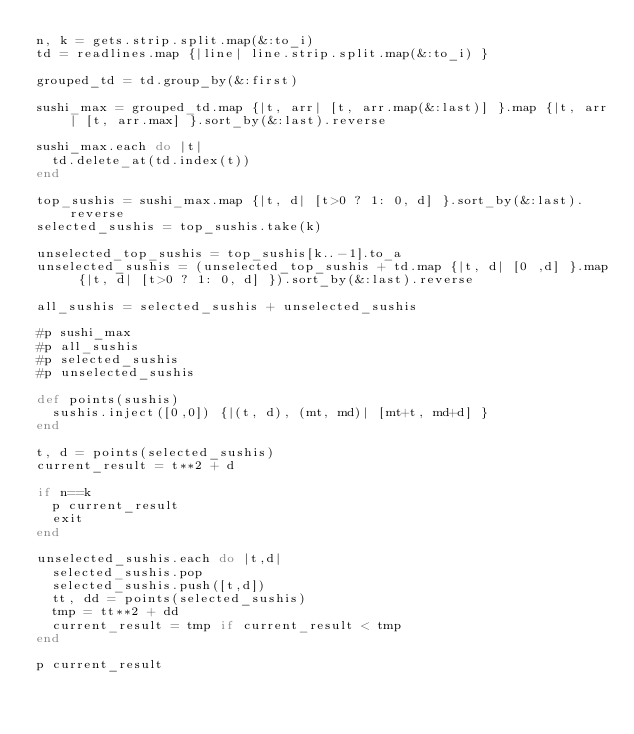Convert code to text. <code><loc_0><loc_0><loc_500><loc_500><_Ruby_>n, k = gets.strip.split.map(&:to_i)
td = readlines.map {|line| line.strip.split.map(&:to_i) }

grouped_td = td.group_by(&:first)

sushi_max = grouped_td.map {|t, arr| [t, arr.map(&:last)] }.map {|t, arr| [t, arr.max] }.sort_by(&:last).reverse

sushi_max.each do |t|
  td.delete_at(td.index(t))
end

top_sushis = sushi_max.map {|t, d| [t>0 ? 1: 0, d] }.sort_by(&:last).reverse
selected_sushis = top_sushis.take(k)

unselected_top_sushis = top_sushis[k..-1].to_a
unselected_sushis = (unselected_top_sushis + td.map {|t, d| [0 ,d] }.map {|t, d| [t>0 ? 1: 0, d] }).sort_by(&:last).reverse

all_sushis = selected_sushis + unselected_sushis

#p sushi_max
#p all_sushis
#p selected_sushis
#p unselected_sushis

def points(sushis)
  sushis.inject([0,0]) {|(t, d), (mt, md)| [mt+t, md+d] }
end

t, d = points(selected_sushis)
current_result = t**2 + d

if n==k
  p current_result
  exit
end

unselected_sushis.each do |t,d|
  selected_sushis.pop
  selected_sushis.push([t,d])
  tt, dd = points(selected_sushis)
  tmp = tt**2 + dd
  current_result = tmp if current_result < tmp
end

p current_result</code> 